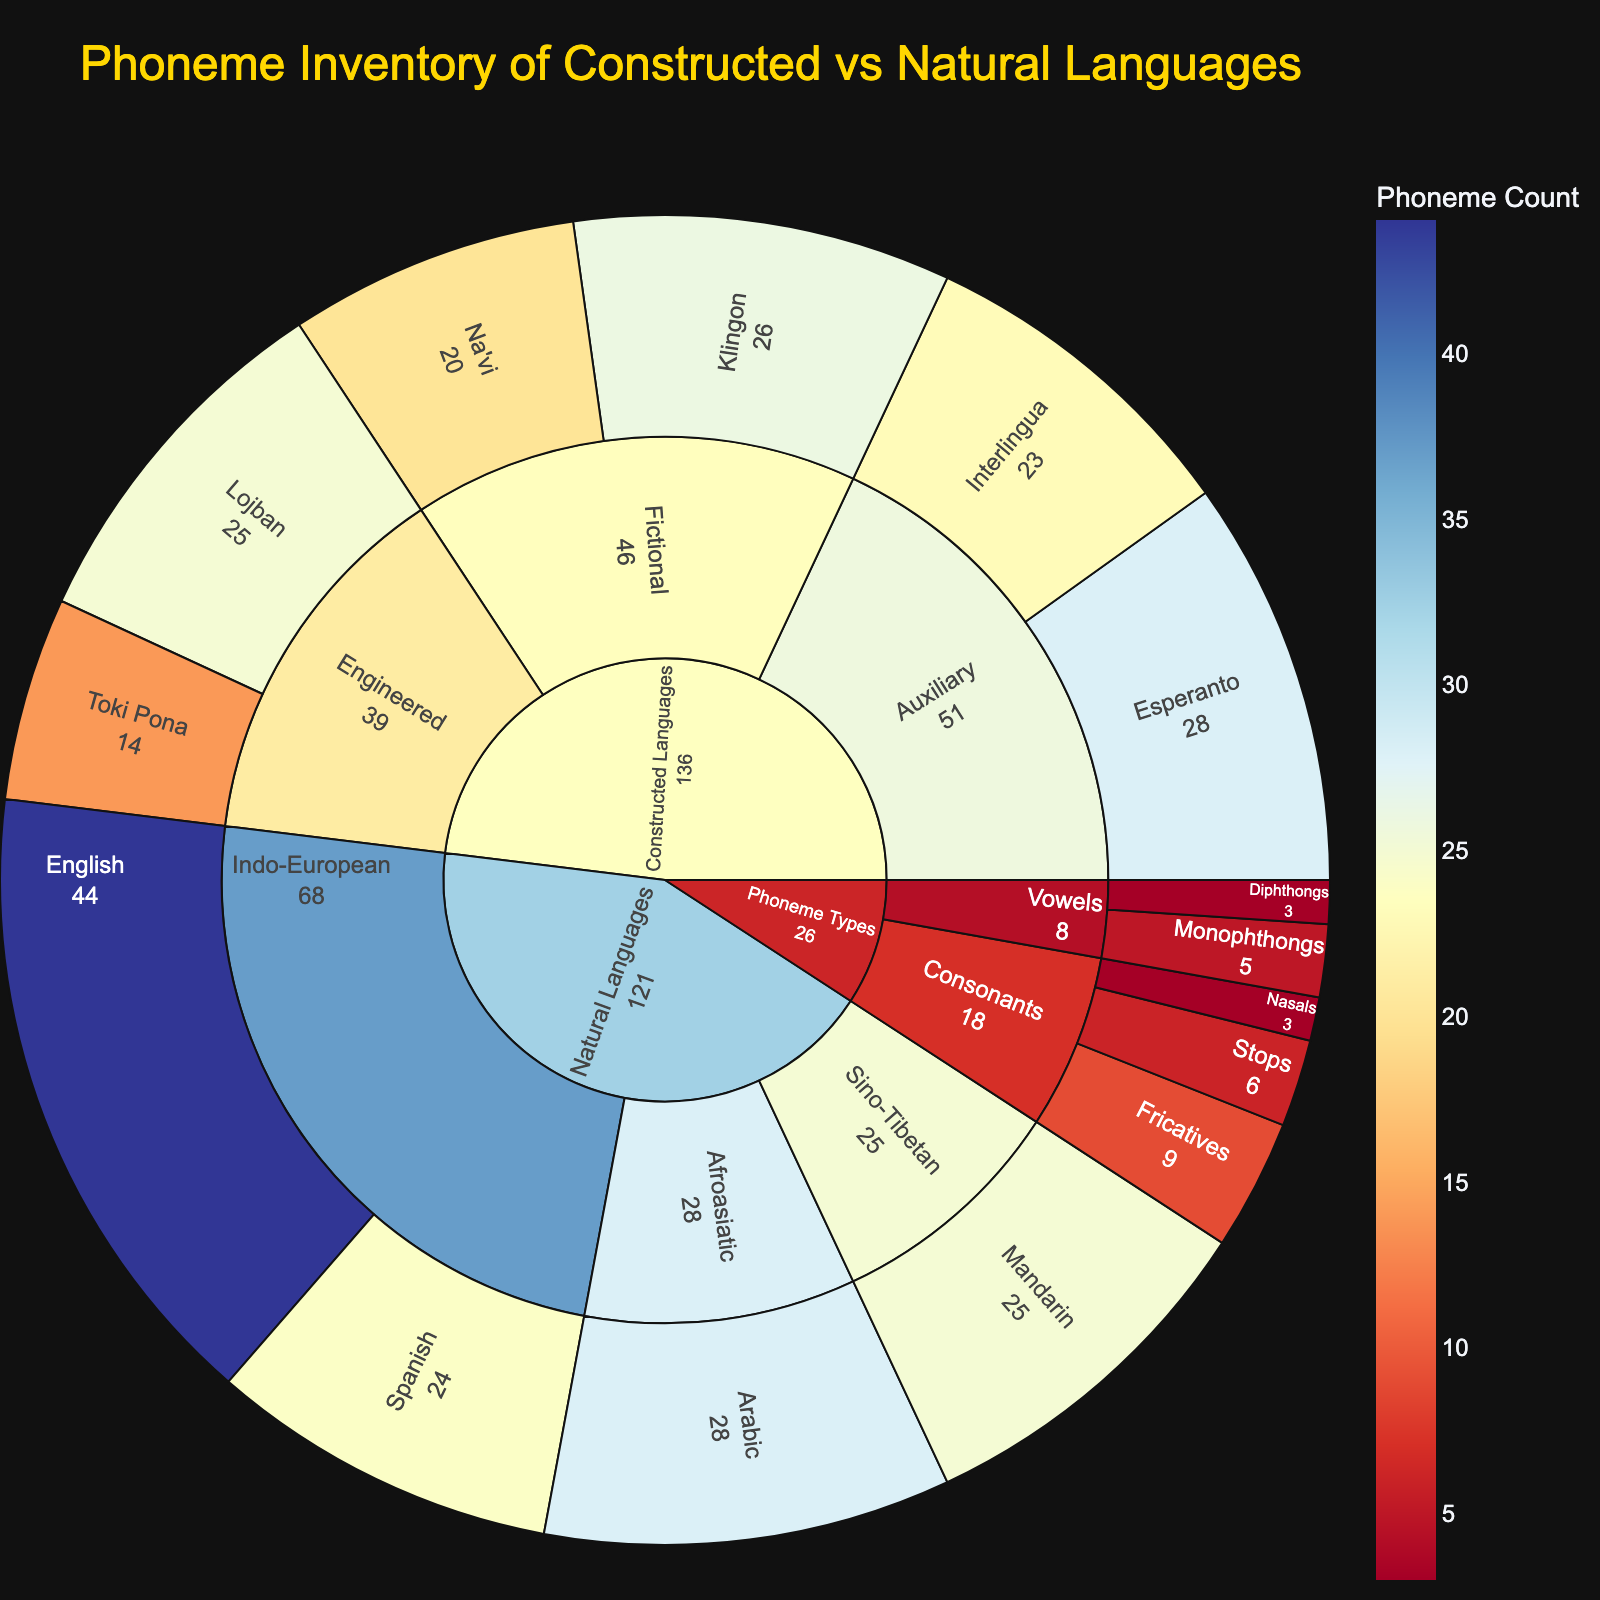What is the total number of natural languages represented in the plot? The plot categorizes data based on 'Category', 'Subcategory', and 'Language'. By looking under the 'Natural Languages' branch, we see there are languages like English, Spanish, Mandarin, and Arabic. Counting these gives us four natural languages.
Answer: 4 What is the phoneme count associated with the constructed fictional language Klingon? Under 'Constructed Languages' > 'Fictional', you will see the entry for Klingon. The phoneme count displayed is 26.
Answer: 26 How does the phoneme count of Arabic compare to that of Mandarin? Under 'Natural Languages', Arabic has a phoneme count of 28, and Mandarin has a count of 25. We compare these values and see that Arabic has three more phonemes.
Answer: Arabic has 3 more phonemes Which constructed language has the highest phoneme count? Examine the branches under 'Constructed Languages'. Among Esperanto, Interlingua, Klingon, Na'vi, Lojban, and Toki Pona, the highest phoneme count is 28 in Esperanto.
Answer: Esperanto What is the average phoneme count of the constructed engineered languages? Under 'Constructed Languages' > 'Engineered', the languages Lojban and Toki Pona have phoneme counts of 25 and 14 respectively. To find the average: (25 + 14) / 2 = 19.5.
Answer: 19.5 Which language category (Natural or Constructed) has more languages represented, and by how many? Count the languages under 'Natural Languages' and 'Constructed Languages'. Natural Languages has 4 (English, Spanish, Mandarin, Arabic), while Constructed Languages has 6 (Esperanto, Interlingua, Klingon, Na'vi, Lojban, Toki Pona). Constructed Languages has 2 more languages.
Answer: Constructed Languages by 2 What is the total phoneme count for Indo-European languages represented in the plot? Under 'Natural Languages' > 'Indo-European', the languages are English (44) and Spanish (24). Summing these gives: 44 + 24 = 68.
Answer: 68 Which language has the fewest phonemes among the constructed languages? By looking at the phoneme counts of all constructed languages (Esperanto, Interlingua, Klingon, Na'vi, Lojban, Toki Pona), the smallest count is for Toki Pona with 14 phonemes.
Answer: Toki Pona Compare the number of vowel phoneme types to consonant phoneme types. Adding the counts in 'Phoneme Types' for vowels gives us Monophthongs (5) and Diphthongs (3) totaling 8. For consonants, Stops (6), Fricatives (9), and Nasals (3) total 18. Consonant phoneme types are greater.
Answer: Consonant phoneme types are greater by 10 What percentage of total represented constructed languages are fictional languages? There are 6 constructed languages in total. Fictional languages include Klingon and Na'vi, making 2. To find the percentage: (2 / 6) * 100% = 33.33%.
Answer: 33.33% 